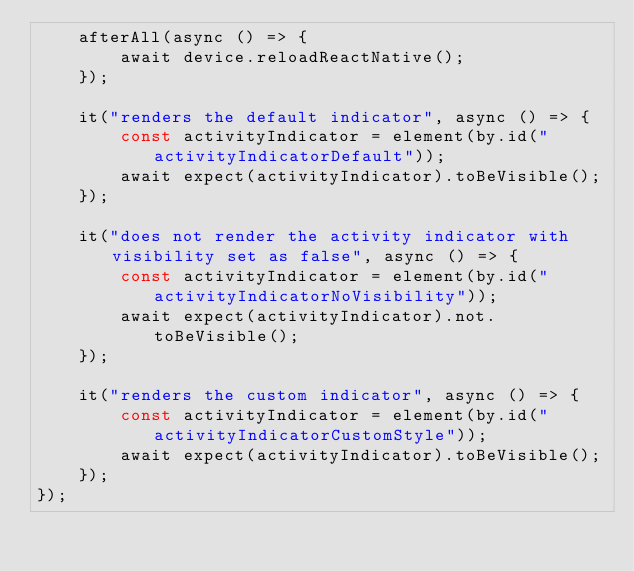Convert code to text. <code><loc_0><loc_0><loc_500><loc_500><_TypeScript_>    afterAll(async () => {
        await device.reloadReactNative();
    });

    it("renders the default indicator", async () => {
        const activityIndicator = element(by.id("activityIndicatorDefault"));
        await expect(activityIndicator).toBeVisible();
    });

    it("does not render the activity indicator with visibility set as false", async () => {
        const activityIndicator = element(by.id("activityIndicatorNoVisibility"));
        await expect(activityIndicator).not.toBeVisible();
    });

    it("renders the custom indicator", async () => {
        const activityIndicator = element(by.id("activityIndicatorCustomStyle"));
        await expect(activityIndicator).toBeVisible();
    });
});
</code> 